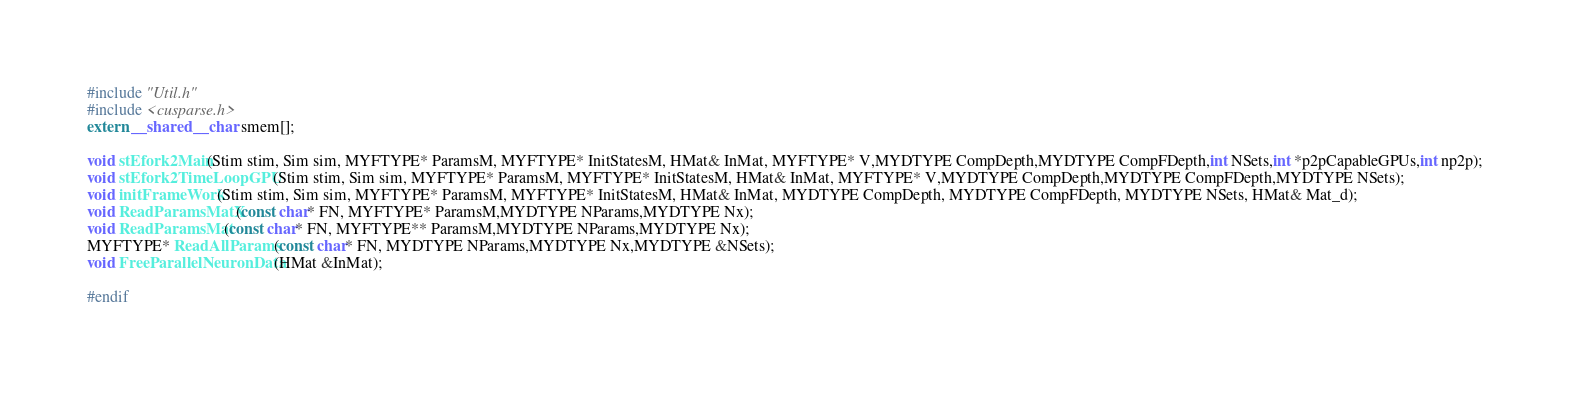<code> <loc_0><loc_0><loc_500><loc_500><_Cuda_>#include "Util.h"
#include <cusparse.h>
extern __shared__ char smem[];

void stEfork2Main(Stim stim, Sim sim, MYFTYPE* ParamsM, MYFTYPE* InitStatesM, HMat& InMat, MYFTYPE* V,MYDTYPE CompDepth,MYDTYPE CompFDepth,int NSets,int *p2pCapableGPUs,int np2p);
void stEfork2TimeLoopGPU(Stim stim, Sim sim, MYFTYPE* ParamsM, MYFTYPE* InitStatesM, HMat& InMat, MYFTYPE* V,MYDTYPE CompDepth,MYDTYPE CompFDepth,MYDTYPE NSets);
void initFrameWork(Stim stim, Sim sim, MYFTYPE* ParamsM, MYFTYPE* InitStatesM, HMat& InMat, MYDTYPE CompDepth, MYDTYPE CompFDepth, MYDTYPE NSets, HMat& Mat_d);
void ReadParamsMatX(const char* FN, MYFTYPE* ParamsM,MYDTYPE NParams,MYDTYPE Nx);
void ReadParamsMat(const char* FN, MYFTYPE** ParamsM,MYDTYPE NParams,MYDTYPE Nx);
MYFTYPE* ReadAllParams(const char* FN, MYDTYPE NParams,MYDTYPE Nx,MYDTYPE &NSets);
void FreeParallelNeuronData(HMat &InMat);

#endif
</code> 